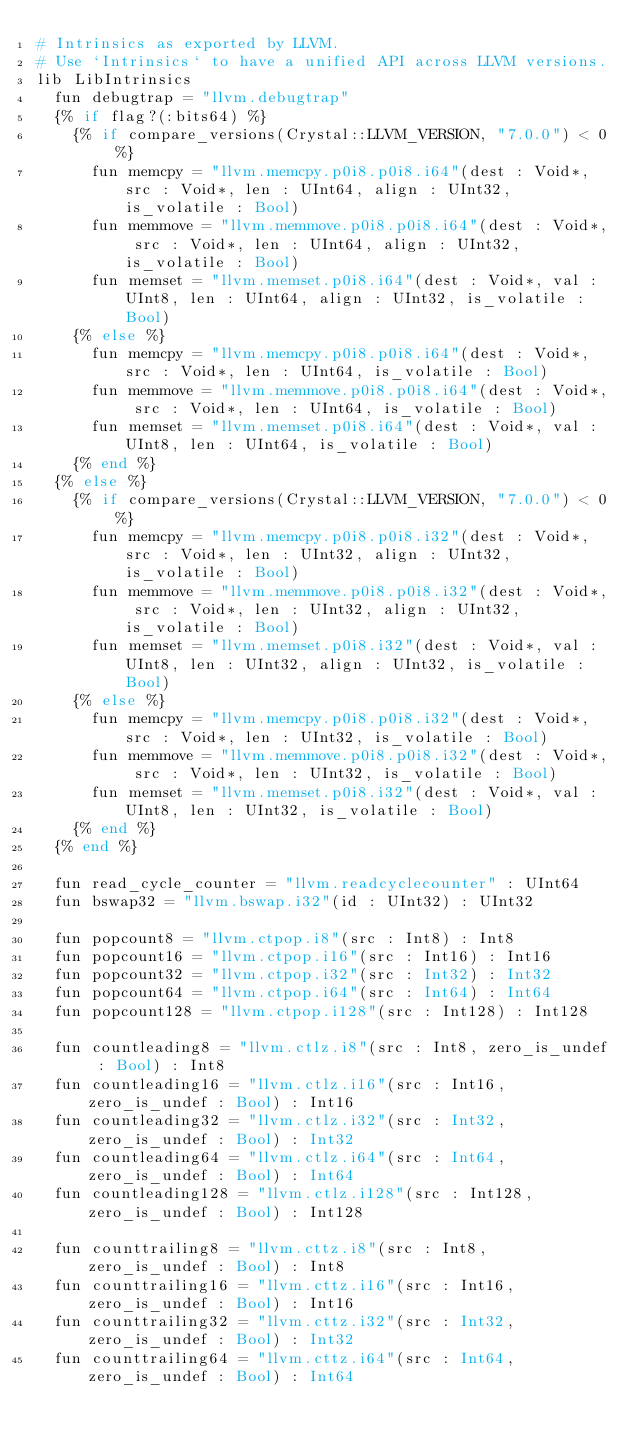Convert code to text. <code><loc_0><loc_0><loc_500><loc_500><_Crystal_># Intrinsics as exported by LLVM.
# Use `Intrinsics` to have a unified API across LLVM versions.
lib LibIntrinsics
  fun debugtrap = "llvm.debugtrap"
  {% if flag?(:bits64) %}
    {% if compare_versions(Crystal::LLVM_VERSION, "7.0.0") < 0 %}
      fun memcpy = "llvm.memcpy.p0i8.p0i8.i64"(dest : Void*, src : Void*, len : UInt64, align : UInt32, is_volatile : Bool)
      fun memmove = "llvm.memmove.p0i8.p0i8.i64"(dest : Void*, src : Void*, len : UInt64, align : UInt32, is_volatile : Bool)
      fun memset = "llvm.memset.p0i8.i64"(dest : Void*, val : UInt8, len : UInt64, align : UInt32, is_volatile : Bool)
    {% else %}
      fun memcpy = "llvm.memcpy.p0i8.p0i8.i64"(dest : Void*, src : Void*, len : UInt64, is_volatile : Bool)
      fun memmove = "llvm.memmove.p0i8.p0i8.i64"(dest : Void*, src : Void*, len : UInt64, is_volatile : Bool)
      fun memset = "llvm.memset.p0i8.i64"(dest : Void*, val : UInt8, len : UInt64, is_volatile : Bool)
    {% end %}
  {% else %}
    {% if compare_versions(Crystal::LLVM_VERSION, "7.0.0") < 0 %}
      fun memcpy = "llvm.memcpy.p0i8.p0i8.i32"(dest : Void*, src : Void*, len : UInt32, align : UInt32, is_volatile : Bool)
      fun memmove = "llvm.memmove.p0i8.p0i8.i32"(dest : Void*, src : Void*, len : UInt32, align : UInt32, is_volatile : Bool)
      fun memset = "llvm.memset.p0i8.i32"(dest : Void*, val : UInt8, len : UInt32, align : UInt32, is_volatile : Bool)
    {% else %}
      fun memcpy = "llvm.memcpy.p0i8.p0i8.i32"(dest : Void*, src : Void*, len : UInt32, is_volatile : Bool)
      fun memmove = "llvm.memmove.p0i8.p0i8.i32"(dest : Void*, src : Void*, len : UInt32, is_volatile : Bool)
      fun memset = "llvm.memset.p0i8.i32"(dest : Void*, val : UInt8, len : UInt32, is_volatile : Bool)
    {% end %}
  {% end %}

  fun read_cycle_counter = "llvm.readcyclecounter" : UInt64
  fun bswap32 = "llvm.bswap.i32"(id : UInt32) : UInt32

  fun popcount8 = "llvm.ctpop.i8"(src : Int8) : Int8
  fun popcount16 = "llvm.ctpop.i16"(src : Int16) : Int16
  fun popcount32 = "llvm.ctpop.i32"(src : Int32) : Int32
  fun popcount64 = "llvm.ctpop.i64"(src : Int64) : Int64
  fun popcount128 = "llvm.ctpop.i128"(src : Int128) : Int128

  fun countleading8 = "llvm.ctlz.i8"(src : Int8, zero_is_undef : Bool) : Int8
  fun countleading16 = "llvm.ctlz.i16"(src : Int16, zero_is_undef : Bool) : Int16
  fun countleading32 = "llvm.ctlz.i32"(src : Int32, zero_is_undef : Bool) : Int32
  fun countleading64 = "llvm.ctlz.i64"(src : Int64, zero_is_undef : Bool) : Int64
  fun countleading128 = "llvm.ctlz.i128"(src : Int128, zero_is_undef : Bool) : Int128

  fun counttrailing8 = "llvm.cttz.i8"(src : Int8, zero_is_undef : Bool) : Int8
  fun counttrailing16 = "llvm.cttz.i16"(src : Int16, zero_is_undef : Bool) : Int16
  fun counttrailing32 = "llvm.cttz.i32"(src : Int32, zero_is_undef : Bool) : Int32
  fun counttrailing64 = "llvm.cttz.i64"(src : Int64, zero_is_undef : Bool) : Int64</code> 